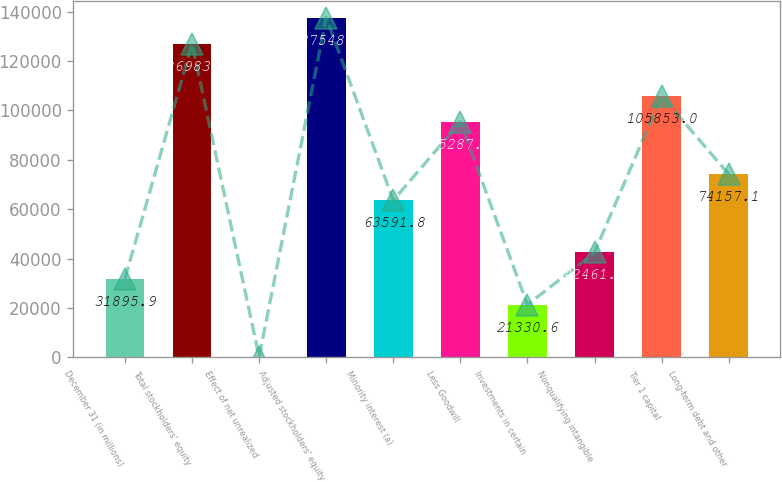<chart> <loc_0><loc_0><loc_500><loc_500><bar_chart><fcel>December 31 (in millions)<fcel>Total stockholders' equity<fcel>Effect of net unrealized<fcel>Adjusted stockholders' equity<fcel>Minority interest (a)<fcel>Less Goodwill<fcel>Investments in certain<fcel>Nonqualifying intangible<fcel>Tier 1 capital<fcel>Long-term debt and other<nl><fcel>31895.9<fcel>126984<fcel>200<fcel>137549<fcel>63591.8<fcel>95287.7<fcel>21330.6<fcel>42461.2<fcel>105853<fcel>74157.1<nl></chart> 